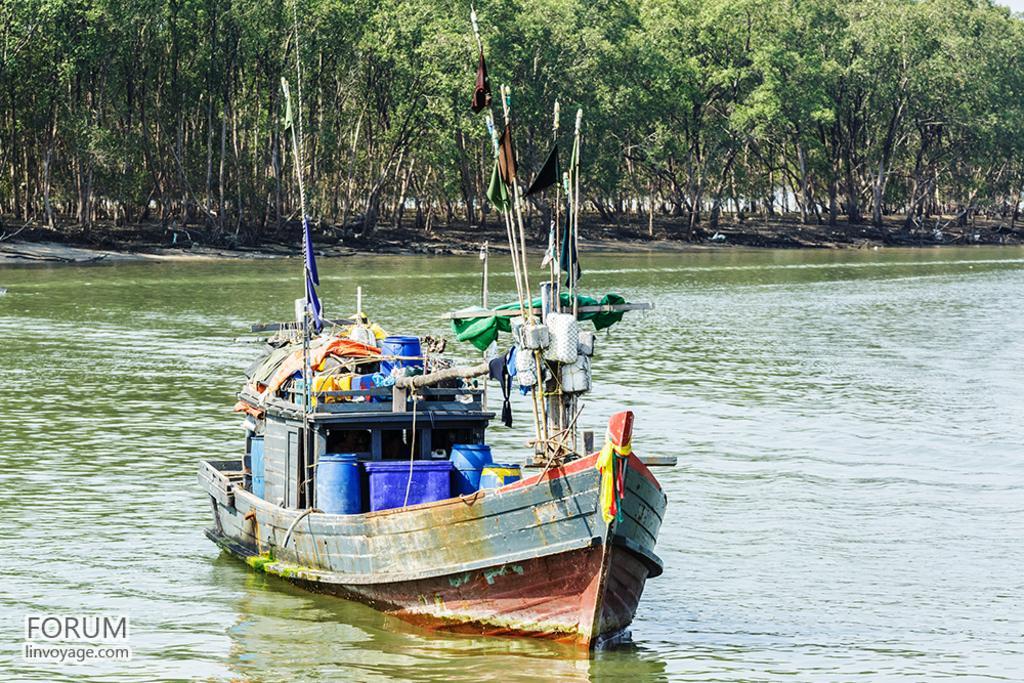Describe this image in one or two sentences. In the middle of the image we can see a boat on the water, in the background we can find few trees, and also we can see few barrels in the boat, at the left bottom of the image we can see some text. 